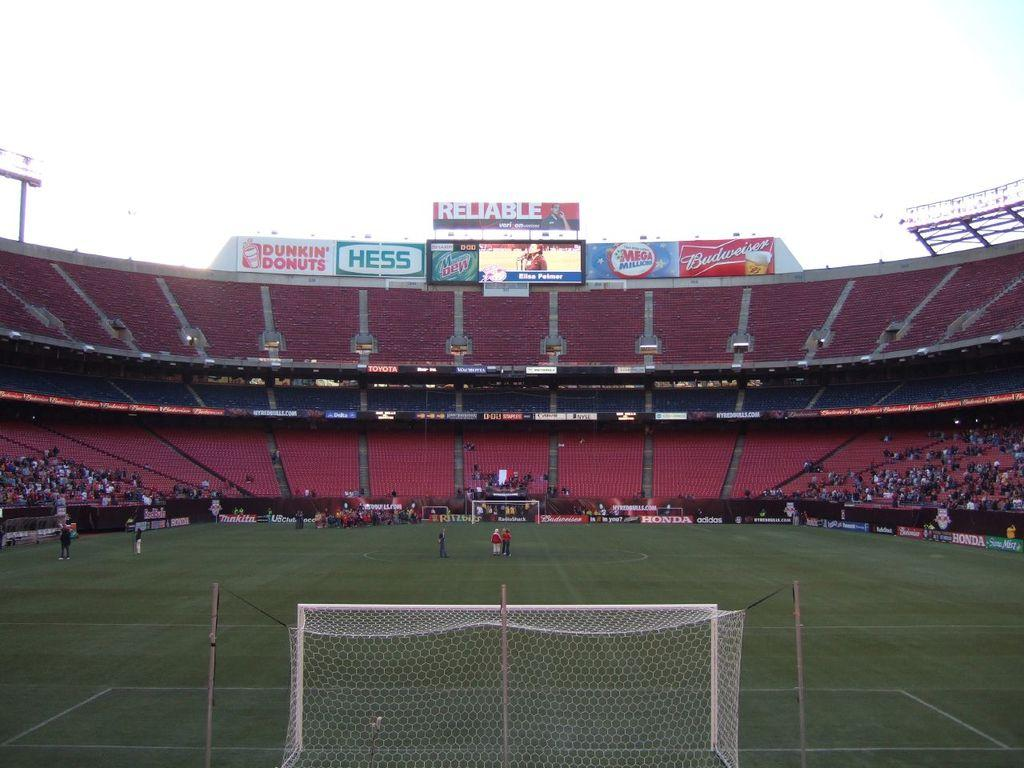<image>
Give a short and clear explanation of the subsequent image. a stadium with mostly empty stands sponsored by hess and dunkin donuts 